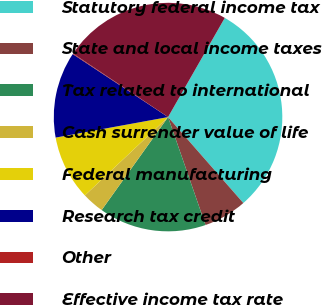Convert chart to OTSL. <chart><loc_0><loc_0><loc_500><loc_500><pie_chart><fcel>Statutory federal income tax<fcel>State and local income taxes<fcel>Tax related to international<fcel>Cash surrender value of life<fcel>Federal manufacturing<fcel>Research tax credit<fcel>Other<fcel>Effective income tax rate<nl><fcel>30.29%<fcel>6.13%<fcel>15.19%<fcel>3.11%<fcel>9.15%<fcel>12.17%<fcel>0.09%<fcel>23.89%<nl></chart> 